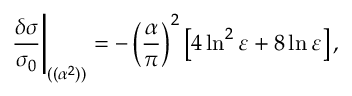Convert formula to latex. <formula><loc_0><loc_0><loc_500><loc_500>{ \frac { \delta \sigma } { \sigma _ { 0 } } } \Big | _ { ( ( \alpha ^ { 2 } ) ) } = - \left ( { \frac { \alpha } { \pi } } \right ) ^ { 2 } \left [ 4 \ln ^ { 2 } \varepsilon + 8 \ln \varepsilon \right ] ,</formula> 